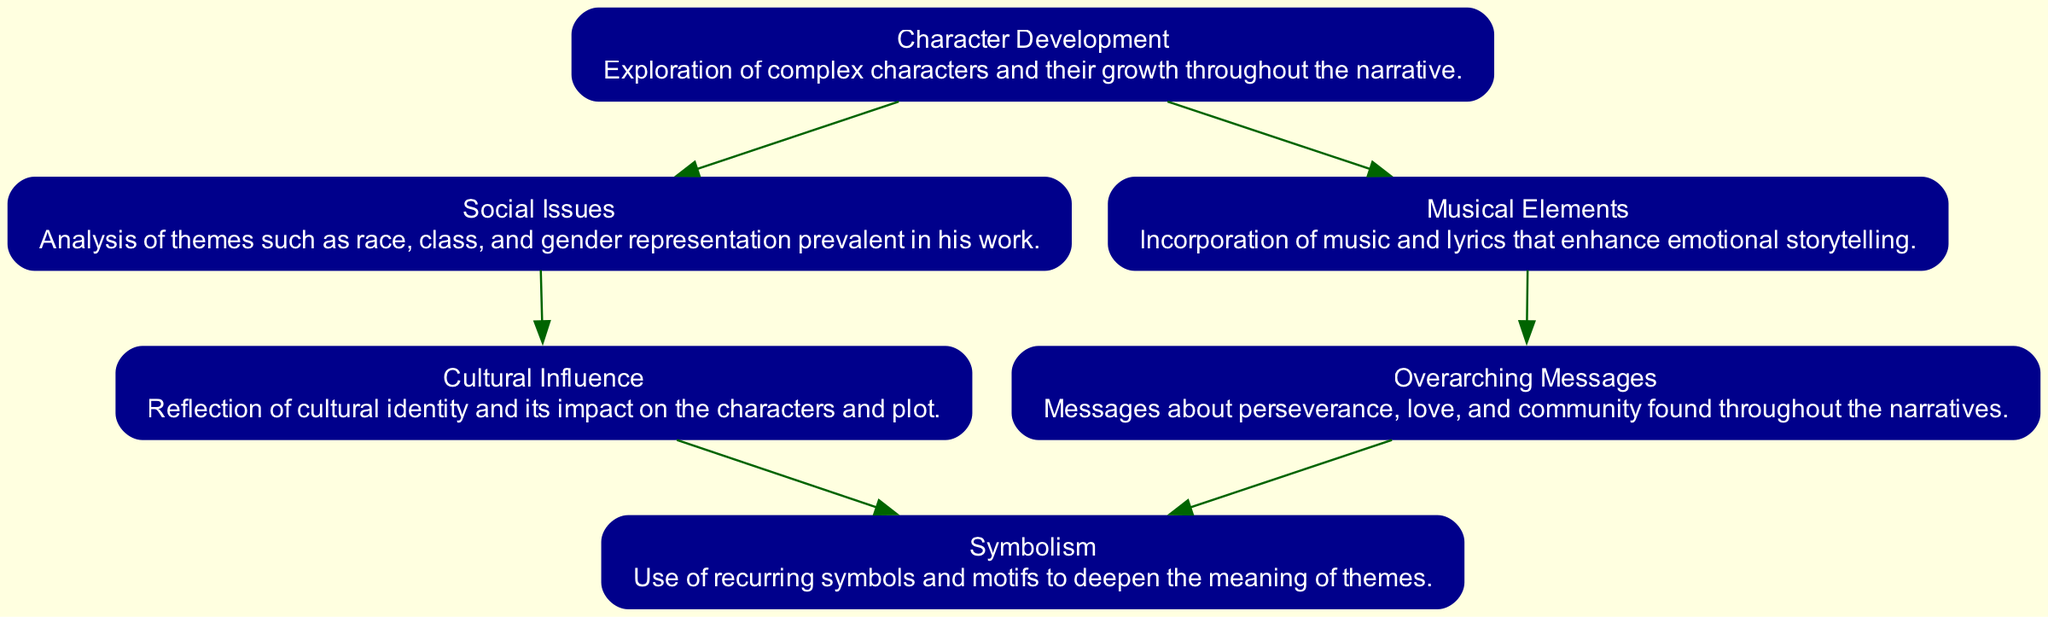What is the first node in the diagram? The first node is labeled "Character Development," which is the beginning of the flow chart.
Answer: Character Development How many nodes are in the diagram? There are 6 nodes in the diagram, representing different themes and messages in Cleve September's work.
Answer: 6 What is the relationship between "Character Development" and "Social Issues"? "Character Development" leads to "Social Issues," indicating that growth in characters often involves engaging with various social themes.
Answer: Leads to Which node represents the theme of love and community? The node labeled "Overarching Messages" includes themes about perseverance, love, and community, reflecting its content.
Answer: Overarching Messages How does "Cultural Influence" relate to "Symbolism"? In the diagram, "Cultural Influence" leads to "Symbolism," suggesting that cultural identity is represented through recurring symbols in the narrative.
Answer: Leads to What color are the edges connecting the nodes? All the edges connecting the nodes are colored dark green, indicating a uniform style throughout the diagram.
Answer: Dark green Which node incorporates music and lyrics? "Musical Elements" is the node that describes the incorporation of music and lyrics to enhance storytelling in Cleve September's work.
Answer: Musical Elements What might "Overarching Messages" convey about the narratives? "Overarching Messages" conveys themes of perseverance, love, and community found throughout the narratives, representing a key takeaway.
Answer: Perseverance, love, and community How does "Character Development" connect to "Musical Elements"? The connection indicates that character development is enhanced by musical elements, showing a relationship between storytelling and music in the diagram.
Answer: Enhances 